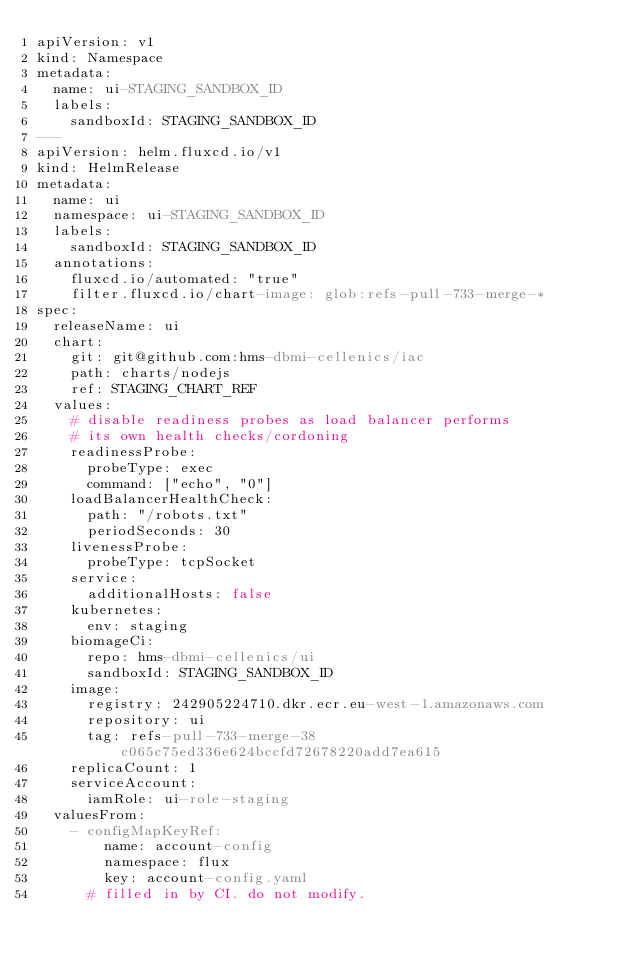Convert code to text. <code><loc_0><loc_0><loc_500><loc_500><_YAML_>apiVersion: v1
kind: Namespace
metadata:
  name: ui-STAGING_SANDBOX_ID
  labels:
    sandboxId: STAGING_SANDBOX_ID
---
apiVersion: helm.fluxcd.io/v1
kind: HelmRelease
metadata:
  name: ui
  namespace: ui-STAGING_SANDBOX_ID
  labels:
    sandboxId: STAGING_SANDBOX_ID
  annotations:
    fluxcd.io/automated: "true"
    filter.fluxcd.io/chart-image: glob:refs-pull-733-merge-*
spec:
  releaseName: ui
  chart:
    git: git@github.com:hms-dbmi-cellenics/iac
    path: charts/nodejs
    ref: STAGING_CHART_REF
  values:
    # disable readiness probes as load balancer performs
    # its own health checks/cordoning
    readinessProbe:
      probeType: exec
      command: ["echo", "0"]
    loadBalancerHealthCheck:
      path: "/robots.txt"
      periodSeconds: 30
    livenessProbe:
      probeType: tcpSocket
    service:
      additionalHosts: false
    kubernetes:
      env: staging
    biomageCi:
      repo: hms-dbmi-cellenics/ui
      sandboxId: STAGING_SANDBOX_ID
    image:
      registry: 242905224710.dkr.ecr.eu-west-1.amazonaws.com
      repository: ui
      tag: refs-pull-733-merge-38c065c75ed336e624bccfd72678220add7ea615
    replicaCount: 1
    serviceAccount:
      iamRole: ui-role-staging
  valuesFrom:
    - configMapKeyRef:
        name: account-config
        namespace: flux
        key: account-config.yaml
      # filled in by CI. do not modify.
</code> 